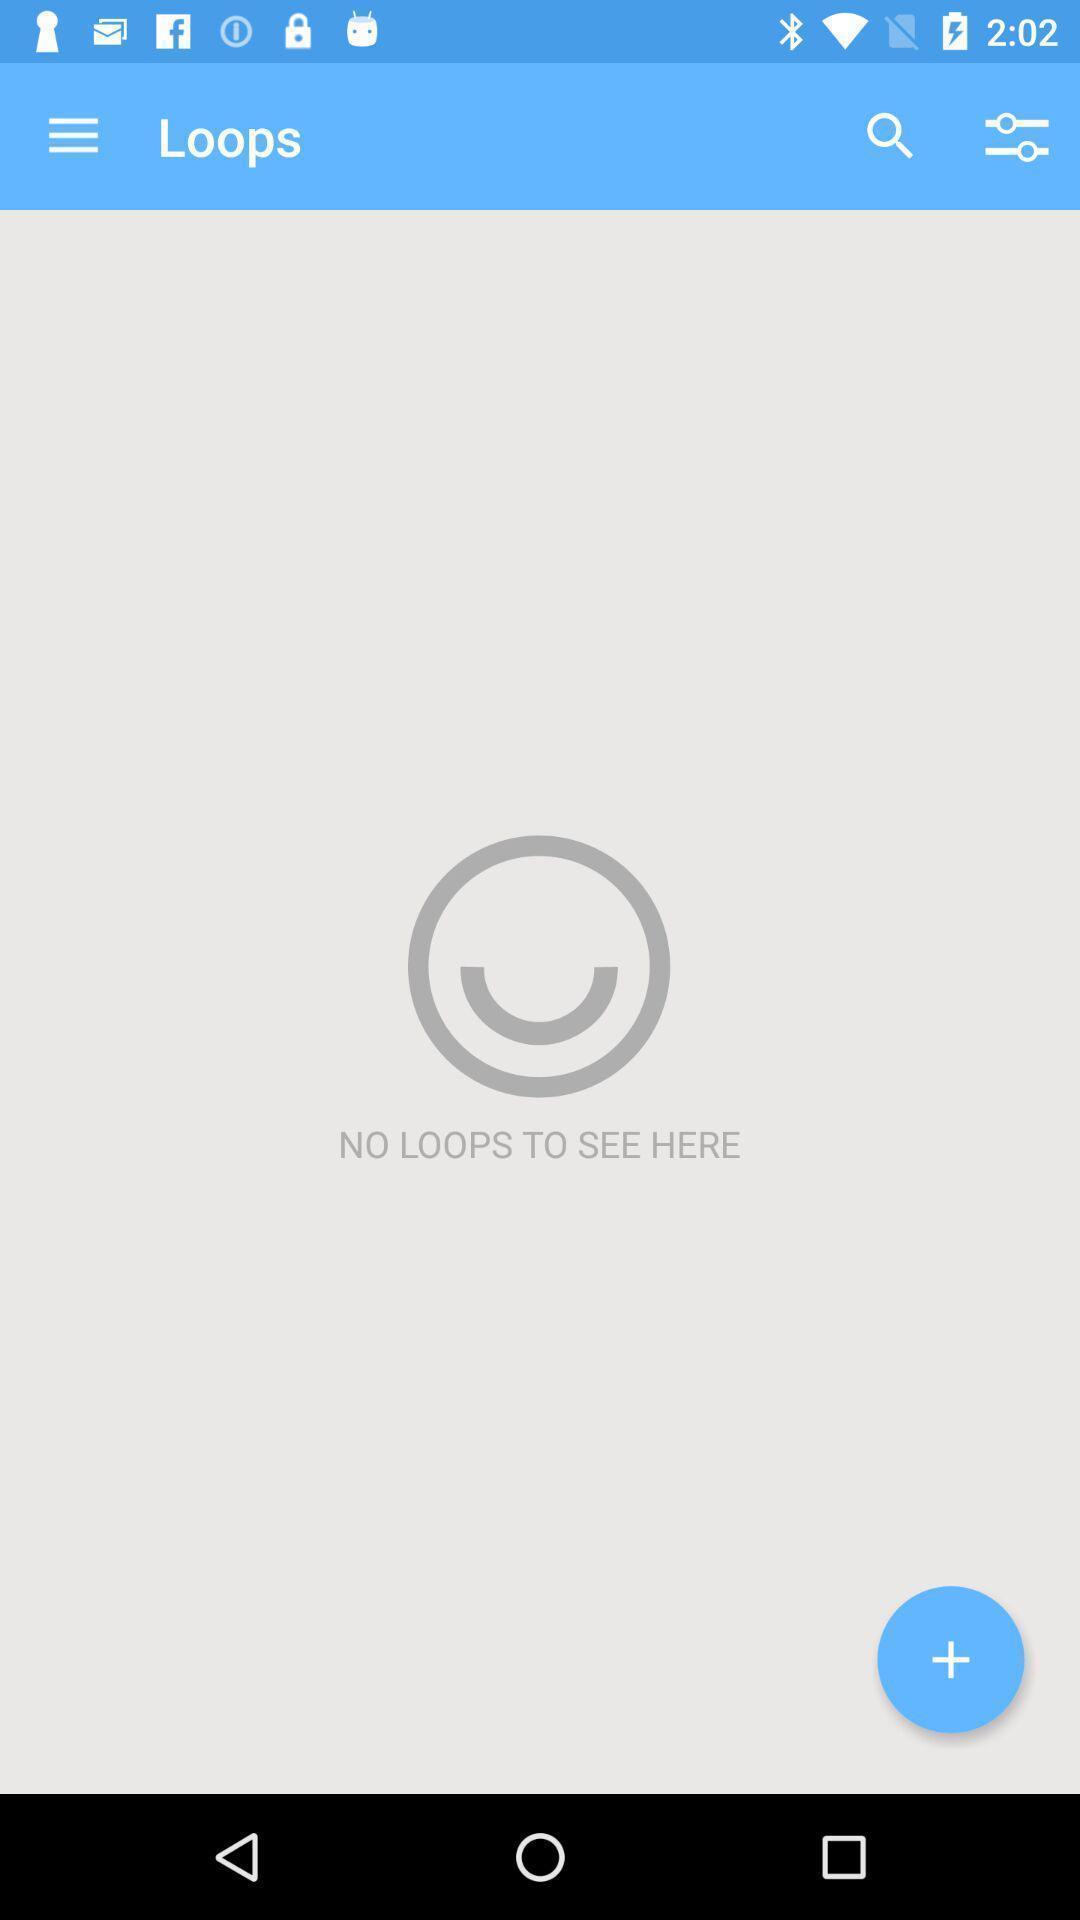Give me a summary of this screen capture. Page to search the loops. 